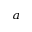Convert formula to latex. <formula><loc_0><loc_0><loc_500><loc_500>^ { a }</formula> 